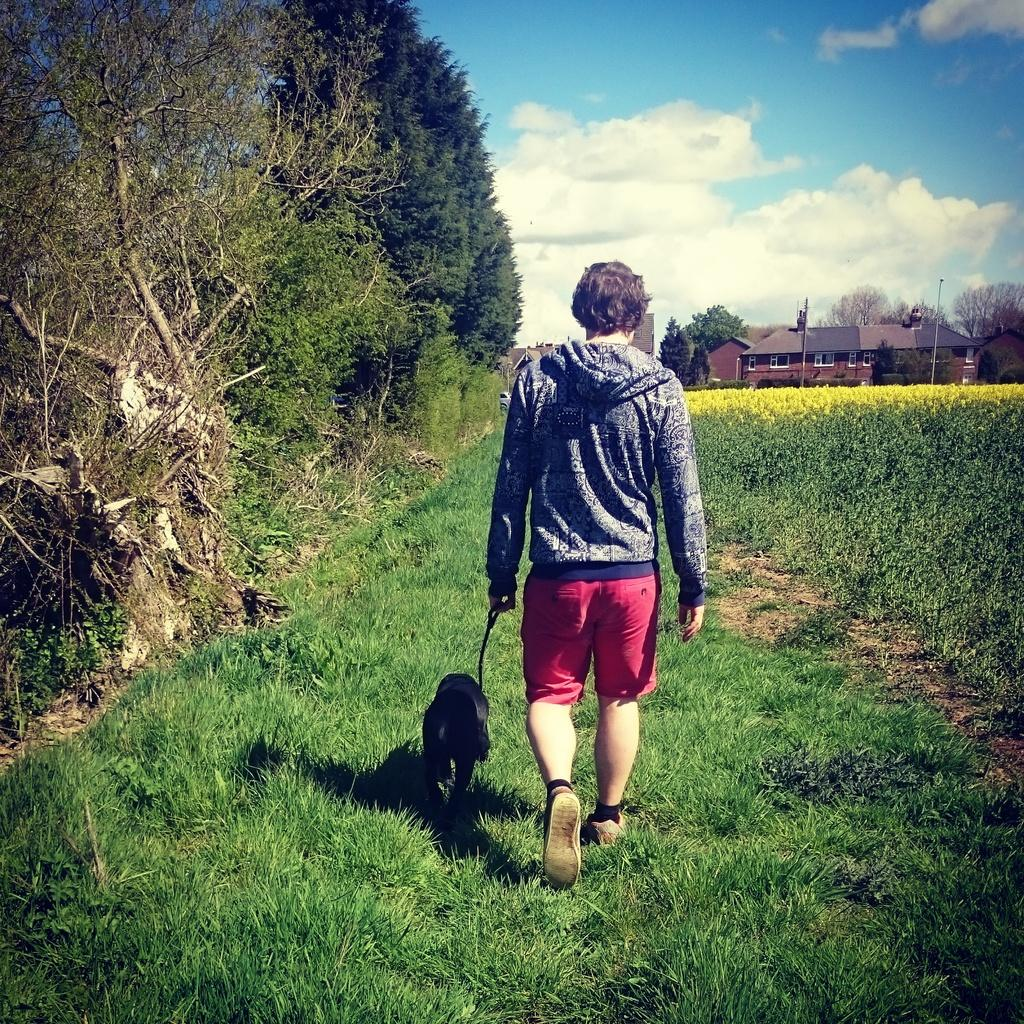What is the main subject of the image? The main subject of the image is a man. What is the man doing in the image? The man is standing and holding a dog. What is the man wearing in the image? The man is wearing a belt. What can be seen in the background of the image? There are trees in the image, and the sky is clear. What type of hammer can be seen in the man's hand in the image? There is no hammer present in the image; the man is holding a dog. Does the existence of the man in the image prove the existence of an error in the image? No, the presence of the man in the image does not prove the existence of an error; he is a clear subject in the image. 